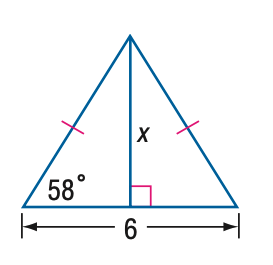What is the significance of the 58 degrees in this image? The 58 degrees in this image indicates one of the base angles of an isosceles triangle. In such triangles, the base angles, which are the angles opposite the equal sides, are equal in measure. This information is crucial as it allows us to determine the measure of the third angle and, using trigonometric ratios or the Law of Sines, find the lengths of the sides. 